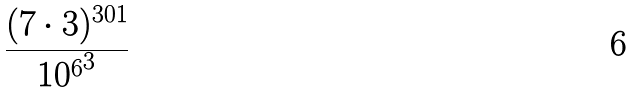Convert formula to latex. <formula><loc_0><loc_0><loc_500><loc_500>\frac { ( 7 \cdot 3 ) ^ { 3 0 1 } } { { 1 0 ^ { 6 } } ^ { 3 } }</formula> 